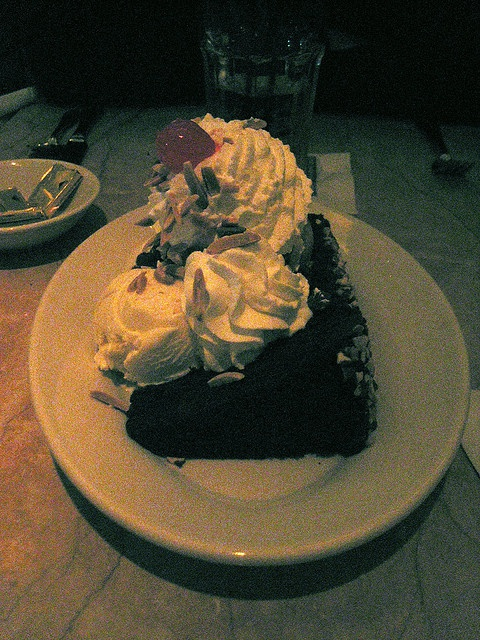Describe the objects in this image and their specific colors. I can see dining table in black, gray, and olive tones, cake in black, tan, gray, and darkgreen tones, cup in black, darkgreen, teal, and gray tones, bowl in black, gray, and olive tones, and fork in black, darkgreen, and teal tones in this image. 